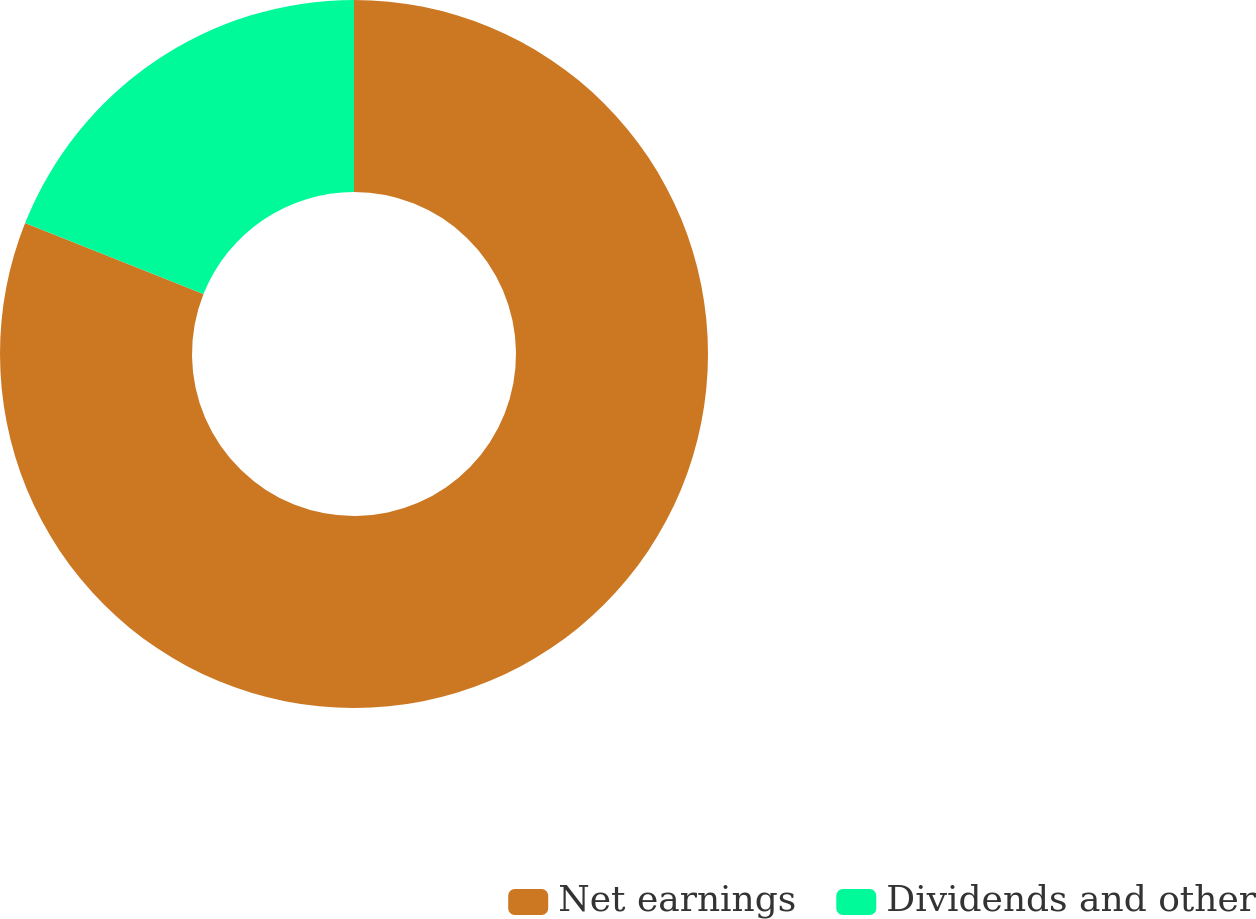Convert chart to OTSL. <chart><loc_0><loc_0><loc_500><loc_500><pie_chart><fcel>Net earnings<fcel>Dividends and other<nl><fcel>81.03%<fcel>18.97%<nl></chart> 